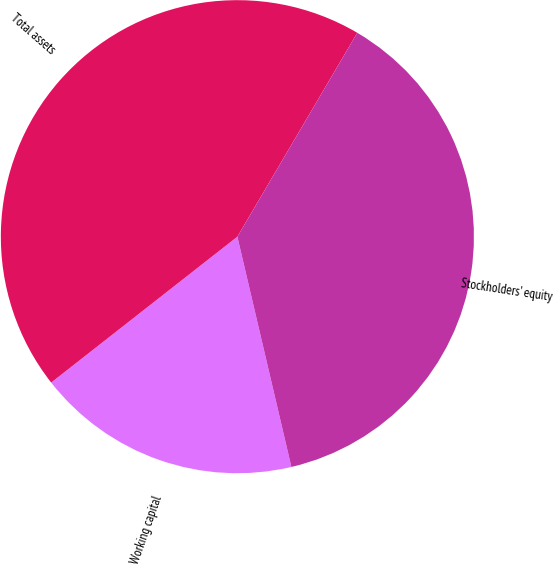Convert chart. <chart><loc_0><loc_0><loc_500><loc_500><pie_chart><fcel>Working capital<fcel>Total assets<fcel>Stockholders' equity<nl><fcel>18.09%<fcel>44.04%<fcel>37.87%<nl></chart> 